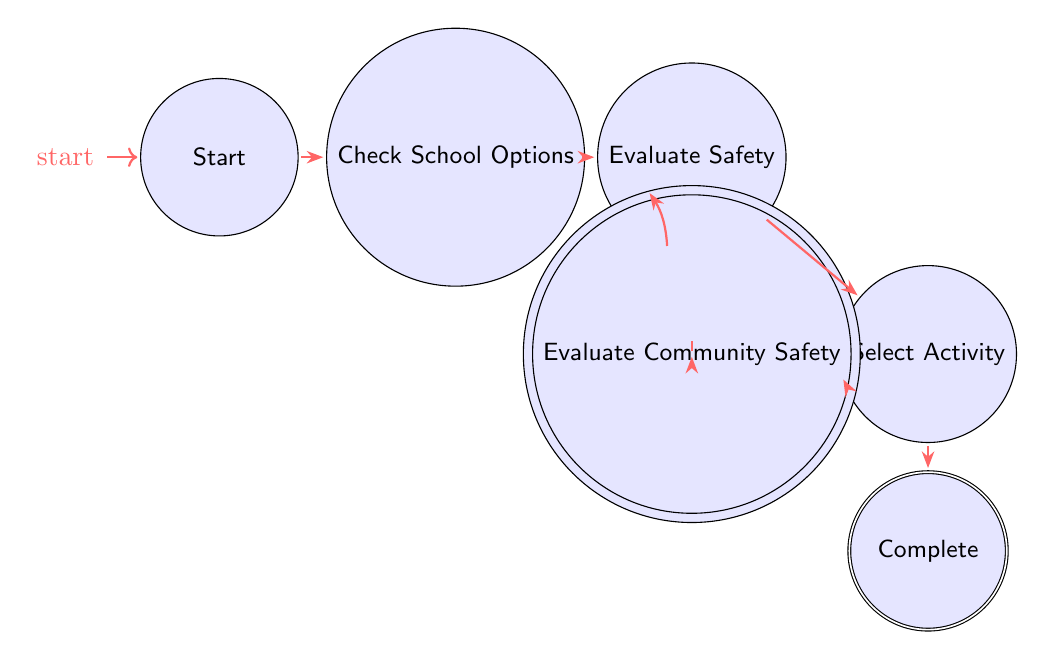What is the first state in the diagram? The first state in the diagram is labeled "Start." This is indicated as the initial state where the sequence of managing extracurricular activities begins.
Answer: Start How many total states are present in the diagram? There are a total of six states in the diagram: Start, Check School Options, Evaluate Safety, Research Community Options, Evaluate Community Safety, Select Activity, and Complete. Counting each state gives us seven distinct states.
Answer: Seven What state comes after "Research Community Options"? Following the state "Research Community Options," the next state is "Evaluate Community Safety." This is shown in the diagram where there is a direct transition from Research Community Options to Evaluate Community Safety.
Answer: Evaluate Community Safety Which state has a transition to both "Select Activity" and "Research Community Options"? The state that has transitions to both "Select Activity" and "Research Community Options" is "Evaluate Safety." This state allows parents to either select an activity based on safety evaluations or explore community options.
Answer: Evaluate Safety What is the final state in the diagram? The final or accepting state in the diagram is "Complete." This indicates the conclusion of the process where the parent successfully enrolls their child in an extracurricular activity.
Answer: Complete Which state requires evaluating safety measures before selecting an activity? The states that require evaluating safety measures before proceeding to select an activity are "Evaluate Safety" and "Evaluate Community Safety." In both cases, safety measures are assessed prior to making a selection.
Answer: Evaluate Safety and Evaluate Community Safety 